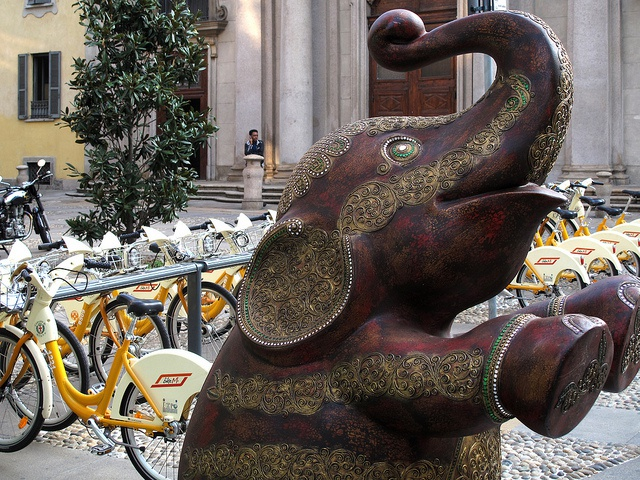Describe the objects in this image and their specific colors. I can see bicycle in tan, white, darkgray, beige, and black tones, bicycle in tan, black, darkgray, gray, and lightgray tones, bicycle in tan, black, darkgray, olive, and gray tones, bicycle in tan, beige, darkgray, black, and gray tones, and motorcycle in tan, black, gray, darkgray, and white tones in this image. 